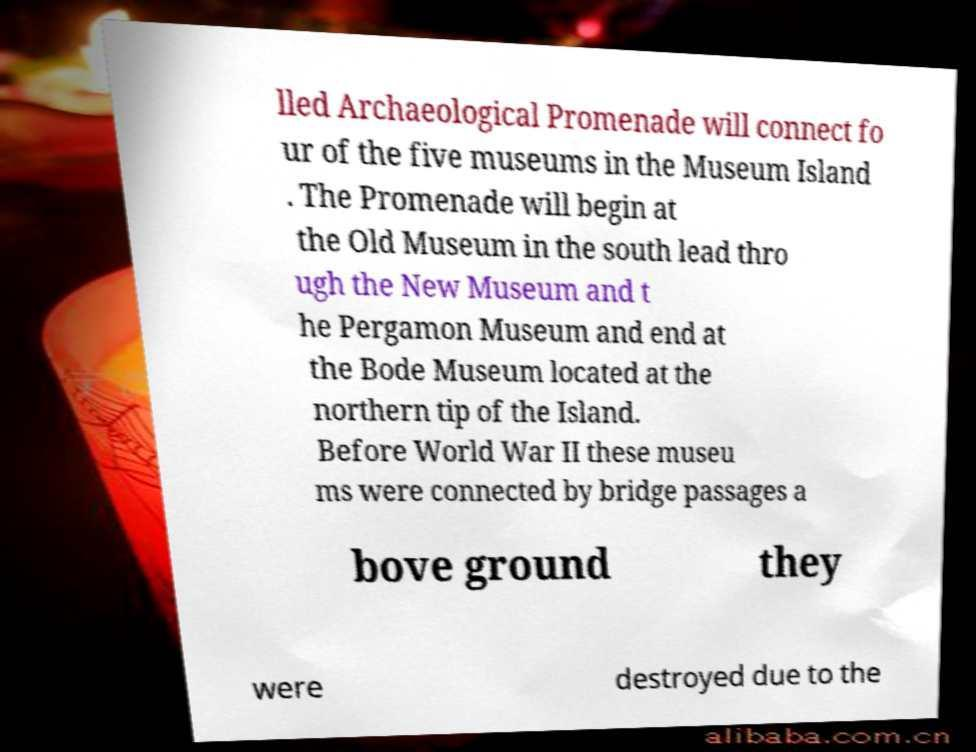Could you extract and type out the text from this image? lled Archaeological Promenade will connect fo ur of the five museums in the Museum Island . The Promenade will begin at the Old Museum in the south lead thro ugh the New Museum and t he Pergamon Museum and end at the Bode Museum located at the northern tip of the Island. Before World War II these museu ms were connected by bridge passages a bove ground they were destroyed due to the 